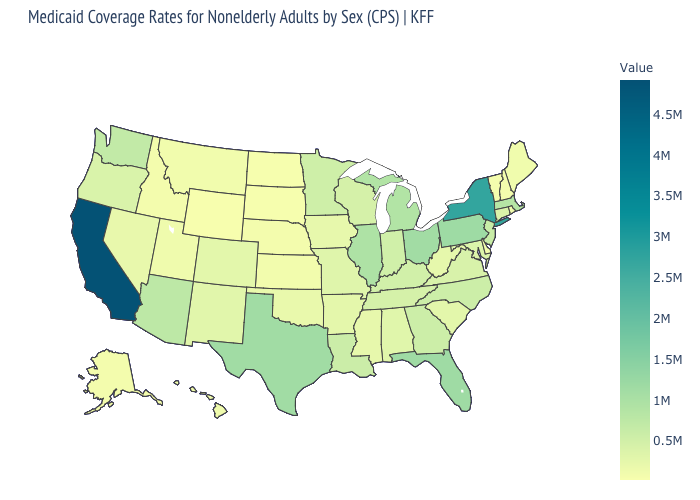Among the states that border North Dakota , which have the lowest value?
Short answer required. South Dakota. Among the states that border Michigan , does Ohio have the highest value?
Answer briefly. Yes. Which states have the lowest value in the USA?
Answer briefly. Wyoming. Does Vermont have the lowest value in the Northeast?
Short answer required. Yes. Does Wyoming have the lowest value in the West?
Keep it brief. Yes. Which states have the lowest value in the USA?
Be succinct. Wyoming. 